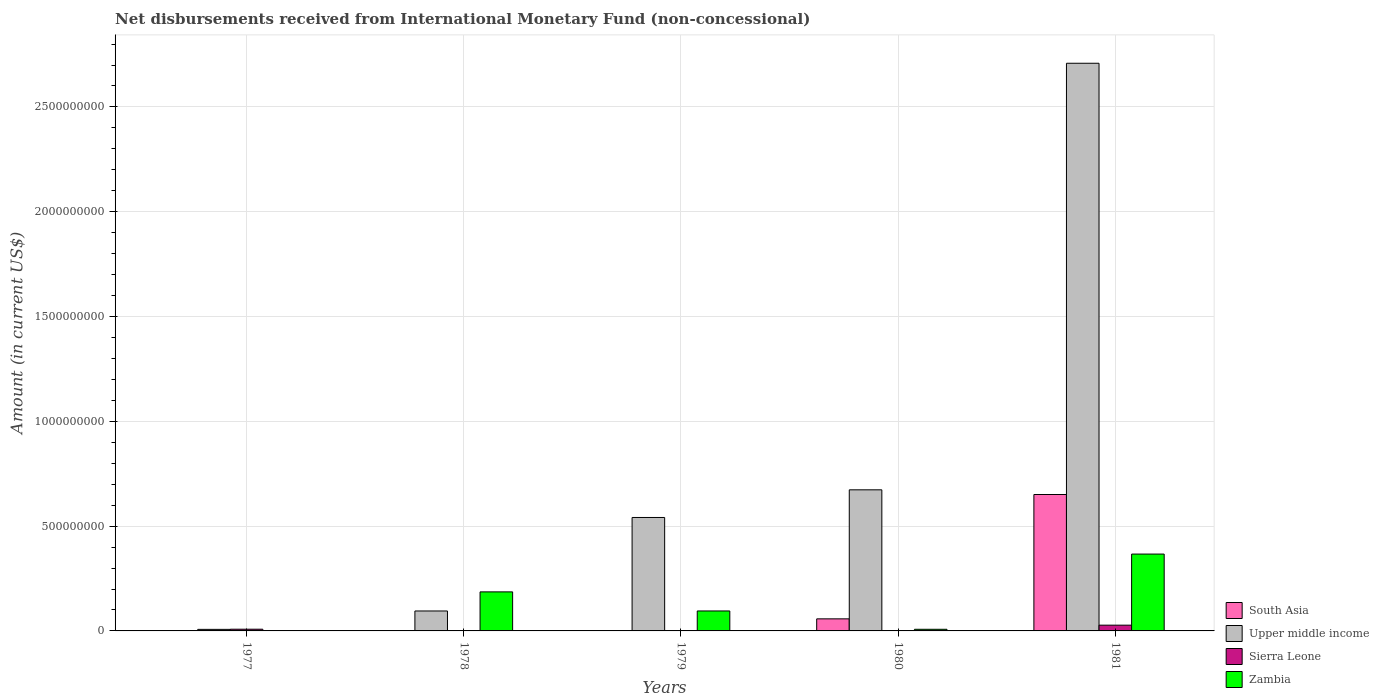How many groups of bars are there?
Your answer should be compact. 5. How many bars are there on the 5th tick from the right?
Provide a succinct answer. 3. What is the label of the 2nd group of bars from the left?
Offer a terse response. 1978. Across all years, what is the maximum amount of disbursements received from International Monetary Fund in Upper middle income?
Make the answer very short. 2.71e+09. Across all years, what is the minimum amount of disbursements received from International Monetary Fund in South Asia?
Provide a short and direct response. 0. What is the total amount of disbursements received from International Monetary Fund in Sierra Leone in the graph?
Offer a terse response. 3.59e+07. What is the difference between the amount of disbursements received from International Monetary Fund in Sierra Leone in 1979 and that in 1981?
Give a very brief answer. -2.72e+07. What is the difference between the amount of disbursements received from International Monetary Fund in Upper middle income in 1981 and the amount of disbursements received from International Monetary Fund in South Asia in 1980?
Make the answer very short. 2.65e+09. What is the average amount of disbursements received from International Monetary Fund in Upper middle income per year?
Offer a terse response. 8.05e+08. In the year 1979, what is the difference between the amount of disbursements received from International Monetary Fund in Sierra Leone and amount of disbursements received from International Monetary Fund in Zambia?
Give a very brief answer. -9.49e+07. What is the ratio of the amount of disbursements received from International Monetary Fund in Zambia in 1977 to that in 1980?
Ensure brevity in your answer.  0. Is the amount of disbursements received from International Monetary Fund in Zambia in 1978 less than that in 1979?
Your answer should be very brief. No. Is the difference between the amount of disbursements received from International Monetary Fund in Sierra Leone in 1977 and 1979 greater than the difference between the amount of disbursements received from International Monetary Fund in Zambia in 1977 and 1979?
Your response must be concise. Yes. What is the difference between the highest and the second highest amount of disbursements received from International Monetary Fund in Sierra Leone?
Make the answer very short. 1.93e+07. What is the difference between the highest and the lowest amount of disbursements received from International Monetary Fund in Sierra Leone?
Your answer should be compact. 2.75e+07. In how many years, is the amount of disbursements received from International Monetary Fund in South Asia greater than the average amount of disbursements received from International Monetary Fund in South Asia taken over all years?
Offer a very short reply. 1. Is it the case that in every year, the sum of the amount of disbursements received from International Monetary Fund in Zambia and amount of disbursements received from International Monetary Fund in Upper middle income is greater than the sum of amount of disbursements received from International Monetary Fund in Sierra Leone and amount of disbursements received from International Monetary Fund in South Asia?
Keep it short and to the point. No. Is it the case that in every year, the sum of the amount of disbursements received from International Monetary Fund in Sierra Leone and amount of disbursements received from International Monetary Fund in South Asia is greater than the amount of disbursements received from International Monetary Fund in Upper middle income?
Give a very brief answer. No. How many bars are there?
Offer a very short reply. 15. Does the graph contain any zero values?
Give a very brief answer. Yes. Does the graph contain grids?
Your response must be concise. Yes. Where does the legend appear in the graph?
Your response must be concise. Bottom right. How many legend labels are there?
Give a very brief answer. 4. How are the legend labels stacked?
Give a very brief answer. Vertical. What is the title of the graph?
Make the answer very short. Net disbursements received from International Monetary Fund (non-concessional). Does "Azerbaijan" appear as one of the legend labels in the graph?
Give a very brief answer. No. What is the Amount (in current US$) in South Asia in 1977?
Offer a terse response. 0. What is the Amount (in current US$) of Upper middle income in 1977?
Offer a terse response. 7.40e+06. What is the Amount (in current US$) of Sierra Leone in 1977?
Your answer should be compact. 8.17e+06. What is the Amount (in current US$) in Zambia in 1977?
Give a very brief answer. 2.30e+04. What is the Amount (in current US$) of Upper middle income in 1978?
Your response must be concise. 9.52e+07. What is the Amount (in current US$) of Sierra Leone in 1978?
Your answer should be very brief. 0. What is the Amount (in current US$) in Zambia in 1978?
Give a very brief answer. 1.86e+08. What is the Amount (in current US$) in South Asia in 1979?
Your answer should be very brief. 0. What is the Amount (in current US$) in Upper middle income in 1979?
Offer a very short reply. 5.41e+08. What is the Amount (in current US$) in Sierra Leone in 1979?
Your answer should be compact. 2.97e+05. What is the Amount (in current US$) in Zambia in 1979?
Give a very brief answer. 9.52e+07. What is the Amount (in current US$) in South Asia in 1980?
Make the answer very short. 5.76e+07. What is the Amount (in current US$) of Upper middle income in 1980?
Your response must be concise. 6.73e+08. What is the Amount (in current US$) in Sierra Leone in 1980?
Offer a terse response. 0. What is the Amount (in current US$) of Zambia in 1980?
Provide a succinct answer. 7.80e+06. What is the Amount (in current US$) of South Asia in 1981?
Your answer should be compact. 6.51e+08. What is the Amount (in current US$) in Upper middle income in 1981?
Your response must be concise. 2.71e+09. What is the Amount (in current US$) in Sierra Leone in 1981?
Offer a terse response. 2.75e+07. What is the Amount (in current US$) of Zambia in 1981?
Give a very brief answer. 3.67e+08. Across all years, what is the maximum Amount (in current US$) of South Asia?
Ensure brevity in your answer.  6.51e+08. Across all years, what is the maximum Amount (in current US$) of Upper middle income?
Offer a very short reply. 2.71e+09. Across all years, what is the maximum Amount (in current US$) in Sierra Leone?
Give a very brief answer. 2.75e+07. Across all years, what is the maximum Amount (in current US$) in Zambia?
Your answer should be very brief. 3.67e+08. Across all years, what is the minimum Amount (in current US$) in South Asia?
Provide a succinct answer. 0. Across all years, what is the minimum Amount (in current US$) of Upper middle income?
Provide a short and direct response. 7.40e+06. Across all years, what is the minimum Amount (in current US$) in Zambia?
Your answer should be very brief. 2.30e+04. What is the total Amount (in current US$) of South Asia in the graph?
Your answer should be very brief. 7.08e+08. What is the total Amount (in current US$) in Upper middle income in the graph?
Make the answer very short. 4.03e+09. What is the total Amount (in current US$) in Sierra Leone in the graph?
Provide a succinct answer. 3.59e+07. What is the total Amount (in current US$) of Zambia in the graph?
Offer a terse response. 6.56e+08. What is the difference between the Amount (in current US$) in Upper middle income in 1977 and that in 1978?
Offer a very short reply. -8.78e+07. What is the difference between the Amount (in current US$) in Zambia in 1977 and that in 1978?
Offer a terse response. -1.86e+08. What is the difference between the Amount (in current US$) in Upper middle income in 1977 and that in 1979?
Provide a succinct answer. -5.34e+08. What is the difference between the Amount (in current US$) in Sierra Leone in 1977 and that in 1979?
Offer a terse response. 7.88e+06. What is the difference between the Amount (in current US$) of Zambia in 1977 and that in 1979?
Provide a succinct answer. -9.52e+07. What is the difference between the Amount (in current US$) in Upper middle income in 1977 and that in 1980?
Offer a terse response. -6.66e+08. What is the difference between the Amount (in current US$) in Zambia in 1977 and that in 1980?
Offer a terse response. -7.78e+06. What is the difference between the Amount (in current US$) in Upper middle income in 1977 and that in 1981?
Provide a succinct answer. -2.70e+09. What is the difference between the Amount (in current US$) of Sierra Leone in 1977 and that in 1981?
Provide a short and direct response. -1.93e+07. What is the difference between the Amount (in current US$) in Zambia in 1977 and that in 1981?
Offer a terse response. -3.67e+08. What is the difference between the Amount (in current US$) in Upper middle income in 1978 and that in 1979?
Provide a short and direct response. -4.46e+08. What is the difference between the Amount (in current US$) of Zambia in 1978 and that in 1979?
Offer a very short reply. 9.11e+07. What is the difference between the Amount (in current US$) in Upper middle income in 1978 and that in 1980?
Your response must be concise. -5.78e+08. What is the difference between the Amount (in current US$) of Zambia in 1978 and that in 1980?
Your answer should be compact. 1.78e+08. What is the difference between the Amount (in current US$) of Upper middle income in 1978 and that in 1981?
Make the answer very short. -2.61e+09. What is the difference between the Amount (in current US$) in Zambia in 1978 and that in 1981?
Offer a very short reply. -1.80e+08. What is the difference between the Amount (in current US$) of Upper middle income in 1979 and that in 1980?
Make the answer very short. -1.32e+08. What is the difference between the Amount (in current US$) of Zambia in 1979 and that in 1980?
Provide a short and direct response. 8.74e+07. What is the difference between the Amount (in current US$) in Upper middle income in 1979 and that in 1981?
Offer a terse response. -2.17e+09. What is the difference between the Amount (in current US$) of Sierra Leone in 1979 and that in 1981?
Provide a short and direct response. -2.72e+07. What is the difference between the Amount (in current US$) of Zambia in 1979 and that in 1981?
Provide a succinct answer. -2.71e+08. What is the difference between the Amount (in current US$) of South Asia in 1980 and that in 1981?
Provide a succinct answer. -5.93e+08. What is the difference between the Amount (in current US$) in Upper middle income in 1980 and that in 1981?
Offer a very short reply. -2.04e+09. What is the difference between the Amount (in current US$) of Zambia in 1980 and that in 1981?
Ensure brevity in your answer.  -3.59e+08. What is the difference between the Amount (in current US$) in Upper middle income in 1977 and the Amount (in current US$) in Zambia in 1978?
Provide a short and direct response. -1.79e+08. What is the difference between the Amount (in current US$) of Sierra Leone in 1977 and the Amount (in current US$) of Zambia in 1978?
Offer a terse response. -1.78e+08. What is the difference between the Amount (in current US$) in Upper middle income in 1977 and the Amount (in current US$) in Sierra Leone in 1979?
Offer a very short reply. 7.10e+06. What is the difference between the Amount (in current US$) in Upper middle income in 1977 and the Amount (in current US$) in Zambia in 1979?
Provide a short and direct response. -8.78e+07. What is the difference between the Amount (in current US$) of Sierra Leone in 1977 and the Amount (in current US$) of Zambia in 1979?
Your answer should be compact. -8.71e+07. What is the difference between the Amount (in current US$) in Upper middle income in 1977 and the Amount (in current US$) in Zambia in 1980?
Your response must be concise. -3.98e+05. What is the difference between the Amount (in current US$) in Sierra Leone in 1977 and the Amount (in current US$) in Zambia in 1980?
Make the answer very short. 3.73e+05. What is the difference between the Amount (in current US$) of Upper middle income in 1977 and the Amount (in current US$) of Sierra Leone in 1981?
Offer a very short reply. -2.01e+07. What is the difference between the Amount (in current US$) of Upper middle income in 1977 and the Amount (in current US$) of Zambia in 1981?
Make the answer very short. -3.59e+08. What is the difference between the Amount (in current US$) of Sierra Leone in 1977 and the Amount (in current US$) of Zambia in 1981?
Ensure brevity in your answer.  -3.59e+08. What is the difference between the Amount (in current US$) of Upper middle income in 1978 and the Amount (in current US$) of Sierra Leone in 1979?
Your answer should be compact. 9.49e+07. What is the difference between the Amount (in current US$) in Upper middle income in 1978 and the Amount (in current US$) in Zambia in 1979?
Offer a very short reply. -7.80e+04. What is the difference between the Amount (in current US$) in Upper middle income in 1978 and the Amount (in current US$) in Zambia in 1980?
Offer a terse response. 8.74e+07. What is the difference between the Amount (in current US$) in Upper middle income in 1978 and the Amount (in current US$) in Sierra Leone in 1981?
Your answer should be very brief. 6.77e+07. What is the difference between the Amount (in current US$) of Upper middle income in 1978 and the Amount (in current US$) of Zambia in 1981?
Provide a short and direct response. -2.72e+08. What is the difference between the Amount (in current US$) in Upper middle income in 1979 and the Amount (in current US$) in Zambia in 1980?
Ensure brevity in your answer.  5.33e+08. What is the difference between the Amount (in current US$) in Sierra Leone in 1979 and the Amount (in current US$) in Zambia in 1980?
Your answer should be compact. -7.50e+06. What is the difference between the Amount (in current US$) in Upper middle income in 1979 and the Amount (in current US$) in Sierra Leone in 1981?
Provide a succinct answer. 5.14e+08. What is the difference between the Amount (in current US$) in Upper middle income in 1979 and the Amount (in current US$) in Zambia in 1981?
Ensure brevity in your answer.  1.75e+08. What is the difference between the Amount (in current US$) of Sierra Leone in 1979 and the Amount (in current US$) of Zambia in 1981?
Ensure brevity in your answer.  -3.66e+08. What is the difference between the Amount (in current US$) of South Asia in 1980 and the Amount (in current US$) of Upper middle income in 1981?
Keep it short and to the point. -2.65e+09. What is the difference between the Amount (in current US$) of South Asia in 1980 and the Amount (in current US$) of Sierra Leone in 1981?
Offer a very short reply. 3.01e+07. What is the difference between the Amount (in current US$) of South Asia in 1980 and the Amount (in current US$) of Zambia in 1981?
Offer a terse response. -3.09e+08. What is the difference between the Amount (in current US$) in Upper middle income in 1980 and the Amount (in current US$) in Sierra Leone in 1981?
Offer a very short reply. 6.46e+08. What is the difference between the Amount (in current US$) in Upper middle income in 1980 and the Amount (in current US$) in Zambia in 1981?
Offer a very short reply. 3.06e+08. What is the average Amount (in current US$) of South Asia per year?
Provide a short and direct response. 1.42e+08. What is the average Amount (in current US$) in Upper middle income per year?
Make the answer very short. 8.05e+08. What is the average Amount (in current US$) of Sierra Leone per year?
Offer a terse response. 7.19e+06. What is the average Amount (in current US$) in Zambia per year?
Offer a terse response. 1.31e+08. In the year 1977, what is the difference between the Amount (in current US$) of Upper middle income and Amount (in current US$) of Sierra Leone?
Your answer should be very brief. -7.71e+05. In the year 1977, what is the difference between the Amount (in current US$) of Upper middle income and Amount (in current US$) of Zambia?
Offer a terse response. 7.38e+06. In the year 1977, what is the difference between the Amount (in current US$) of Sierra Leone and Amount (in current US$) of Zambia?
Give a very brief answer. 8.15e+06. In the year 1978, what is the difference between the Amount (in current US$) in Upper middle income and Amount (in current US$) in Zambia?
Give a very brief answer. -9.11e+07. In the year 1979, what is the difference between the Amount (in current US$) in Upper middle income and Amount (in current US$) in Sierra Leone?
Make the answer very short. 5.41e+08. In the year 1979, what is the difference between the Amount (in current US$) in Upper middle income and Amount (in current US$) in Zambia?
Offer a terse response. 4.46e+08. In the year 1979, what is the difference between the Amount (in current US$) of Sierra Leone and Amount (in current US$) of Zambia?
Make the answer very short. -9.49e+07. In the year 1980, what is the difference between the Amount (in current US$) of South Asia and Amount (in current US$) of Upper middle income?
Offer a terse response. -6.16e+08. In the year 1980, what is the difference between the Amount (in current US$) in South Asia and Amount (in current US$) in Zambia?
Your answer should be very brief. 4.98e+07. In the year 1980, what is the difference between the Amount (in current US$) in Upper middle income and Amount (in current US$) in Zambia?
Keep it short and to the point. 6.65e+08. In the year 1981, what is the difference between the Amount (in current US$) of South Asia and Amount (in current US$) of Upper middle income?
Provide a succinct answer. -2.06e+09. In the year 1981, what is the difference between the Amount (in current US$) of South Asia and Amount (in current US$) of Sierra Leone?
Provide a succinct answer. 6.23e+08. In the year 1981, what is the difference between the Amount (in current US$) in South Asia and Amount (in current US$) in Zambia?
Your answer should be compact. 2.84e+08. In the year 1981, what is the difference between the Amount (in current US$) in Upper middle income and Amount (in current US$) in Sierra Leone?
Ensure brevity in your answer.  2.68e+09. In the year 1981, what is the difference between the Amount (in current US$) of Upper middle income and Amount (in current US$) of Zambia?
Your answer should be very brief. 2.34e+09. In the year 1981, what is the difference between the Amount (in current US$) of Sierra Leone and Amount (in current US$) of Zambia?
Offer a very short reply. -3.39e+08. What is the ratio of the Amount (in current US$) in Upper middle income in 1977 to that in 1978?
Offer a terse response. 0.08. What is the ratio of the Amount (in current US$) in Zambia in 1977 to that in 1978?
Provide a short and direct response. 0. What is the ratio of the Amount (in current US$) in Upper middle income in 1977 to that in 1979?
Make the answer very short. 0.01. What is the ratio of the Amount (in current US$) of Sierra Leone in 1977 to that in 1979?
Your response must be concise. 27.52. What is the ratio of the Amount (in current US$) in Zambia in 1977 to that in 1979?
Make the answer very short. 0. What is the ratio of the Amount (in current US$) of Upper middle income in 1977 to that in 1980?
Offer a terse response. 0.01. What is the ratio of the Amount (in current US$) in Zambia in 1977 to that in 1980?
Your answer should be very brief. 0. What is the ratio of the Amount (in current US$) in Upper middle income in 1977 to that in 1981?
Your response must be concise. 0. What is the ratio of the Amount (in current US$) in Sierra Leone in 1977 to that in 1981?
Offer a terse response. 0.3. What is the ratio of the Amount (in current US$) in Upper middle income in 1978 to that in 1979?
Give a very brief answer. 0.18. What is the ratio of the Amount (in current US$) of Zambia in 1978 to that in 1979?
Ensure brevity in your answer.  1.96. What is the ratio of the Amount (in current US$) in Upper middle income in 1978 to that in 1980?
Provide a short and direct response. 0.14. What is the ratio of the Amount (in current US$) of Zambia in 1978 to that in 1980?
Offer a very short reply. 23.88. What is the ratio of the Amount (in current US$) in Upper middle income in 1978 to that in 1981?
Give a very brief answer. 0.04. What is the ratio of the Amount (in current US$) in Zambia in 1978 to that in 1981?
Give a very brief answer. 0.51. What is the ratio of the Amount (in current US$) of Upper middle income in 1979 to that in 1980?
Provide a succinct answer. 0.8. What is the ratio of the Amount (in current US$) of Zambia in 1979 to that in 1980?
Give a very brief answer. 12.21. What is the ratio of the Amount (in current US$) in Upper middle income in 1979 to that in 1981?
Your response must be concise. 0.2. What is the ratio of the Amount (in current US$) of Sierra Leone in 1979 to that in 1981?
Ensure brevity in your answer.  0.01. What is the ratio of the Amount (in current US$) of Zambia in 1979 to that in 1981?
Give a very brief answer. 0.26. What is the ratio of the Amount (in current US$) of South Asia in 1980 to that in 1981?
Offer a very short reply. 0.09. What is the ratio of the Amount (in current US$) in Upper middle income in 1980 to that in 1981?
Ensure brevity in your answer.  0.25. What is the ratio of the Amount (in current US$) of Zambia in 1980 to that in 1981?
Make the answer very short. 0.02. What is the difference between the highest and the second highest Amount (in current US$) of Upper middle income?
Offer a very short reply. 2.04e+09. What is the difference between the highest and the second highest Amount (in current US$) in Sierra Leone?
Offer a terse response. 1.93e+07. What is the difference between the highest and the second highest Amount (in current US$) in Zambia?
Offer a terse response. 1.80e+08. What is the difference between the highest and the lowest Amount (in current US$) of South Asia?
Offer a very short reply. 6.51e+08. What is the difference between the highest and the lowest Amount (in current US$) of Upper middle income?
Offer a terse response. 2.70e+09. What is the difference between the highest and the lowest Amount (in current US$) in Sierra Leone?
Your answer should be very brief. 2.75e+07. What is the difference between the highest and the lowest Amount (in current US$) in Zambia?
Offer a terse response. 3.67e+08. 